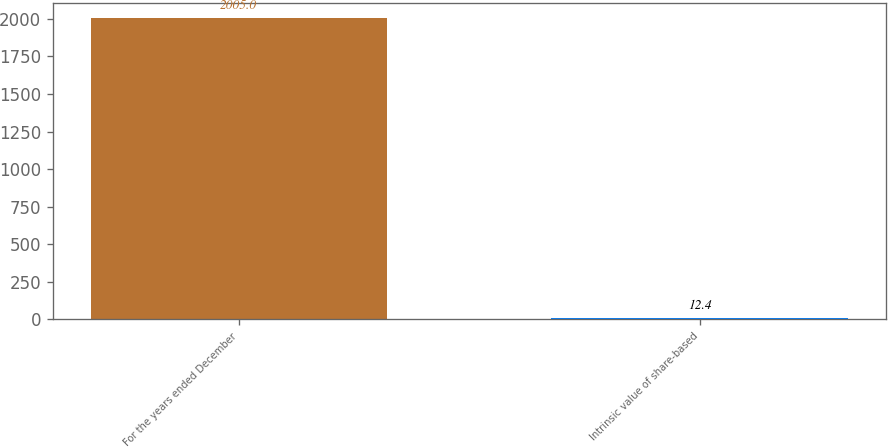<chart> <loc_0><loc_0><loc_500><loc_500><bar_chart><fcel>For the years ended December<fcel>Intrinsic value of share-based<nl><fcel>2005<fcel>12.4<nl></chart> 